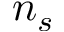Convert formula to latex. <formula><loc_0><loc_0><loc_500><loc_500>n _ { s }</formula> 